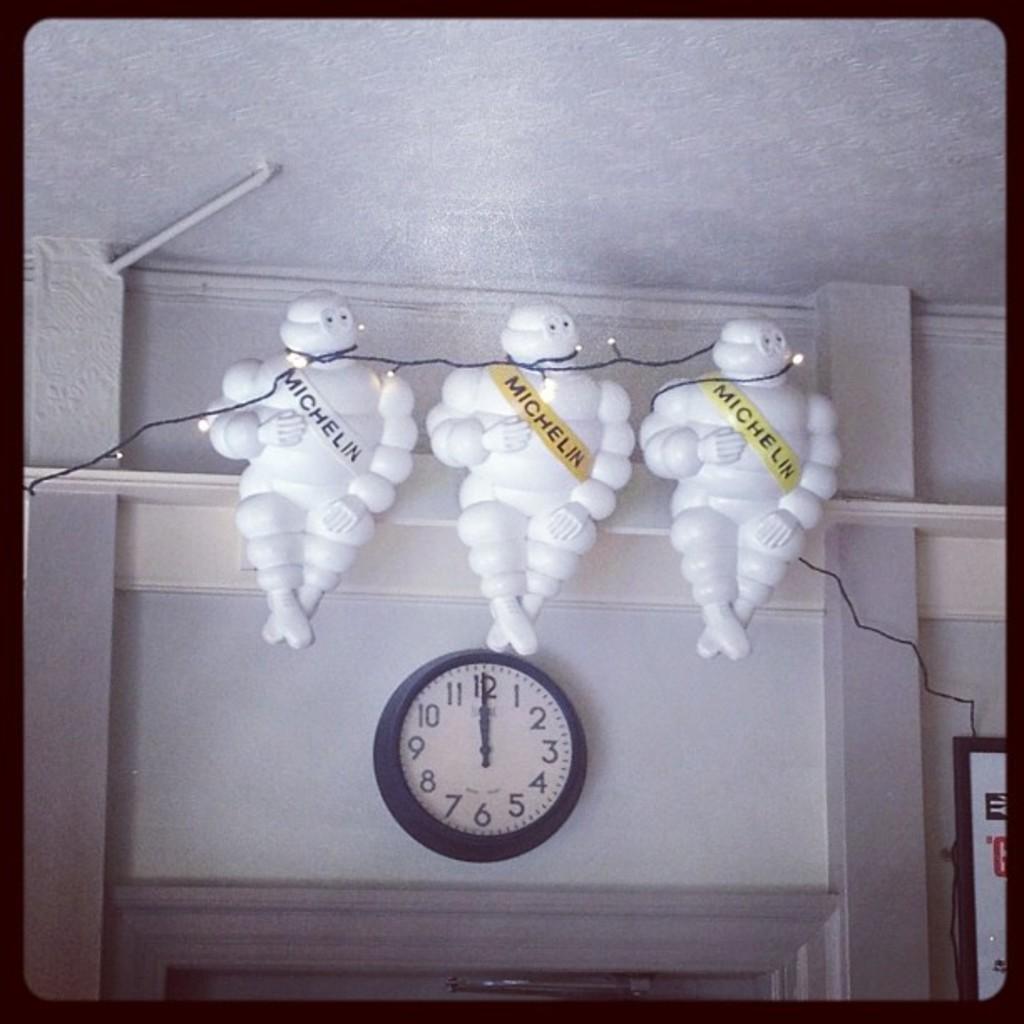What time does the clock on the wall have?
Offer a very short reply. 12:00. What company is written on the puffy men above the clock?
Ensure brevity in your answer.  Michelin. 